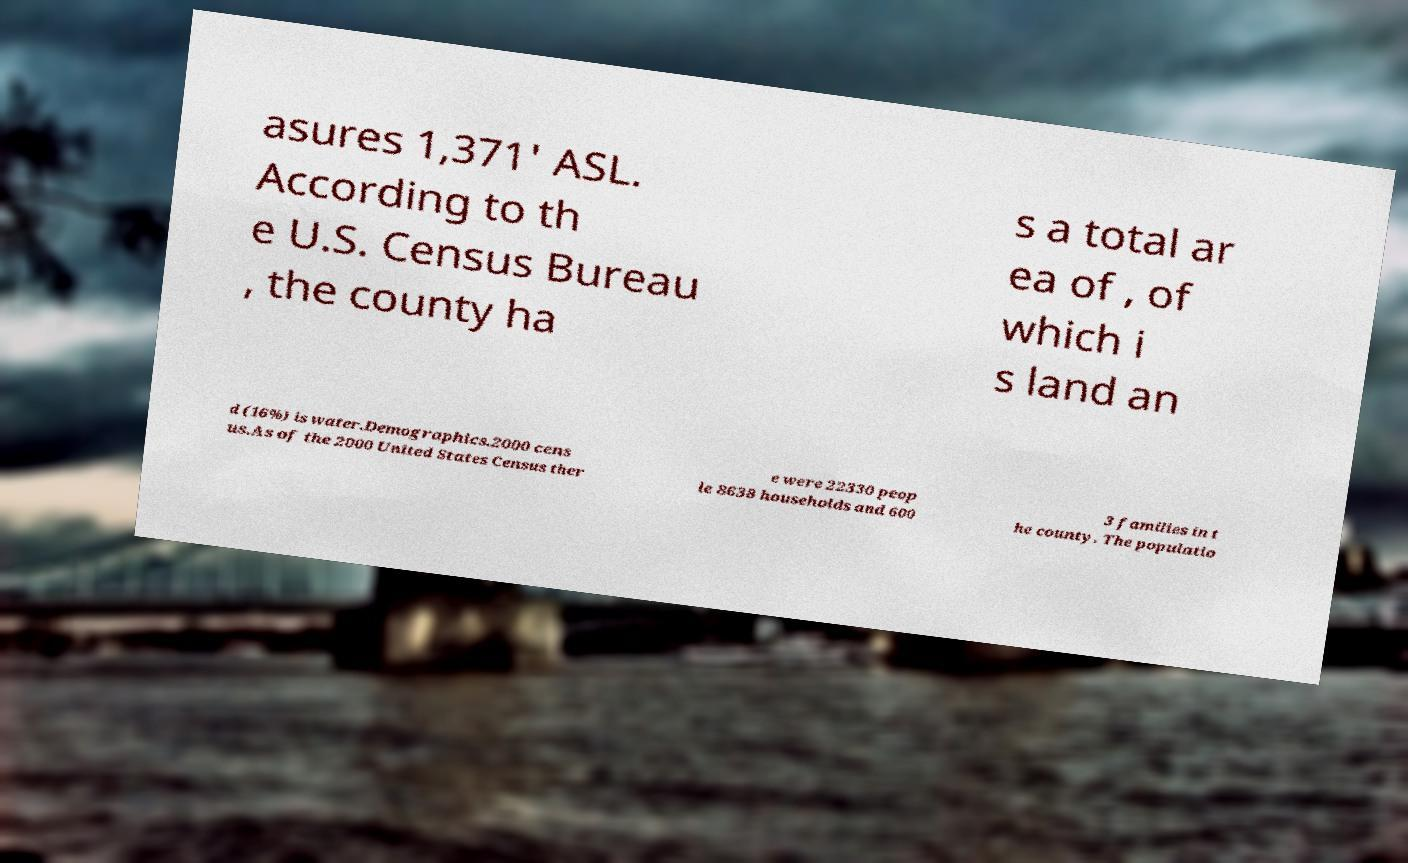Please read and relay the text visible in this image. What does it say? asures 1,371' ASL. According to th e U.S. Census Bureau , the county ha s a total ar ea of , of which i s land an d (16%) is water.Demographics.2000 cens us.As of the 2000 United States Census ther e were 22330 peop le 8638 households and 600 3 families in t he county. The populatio 